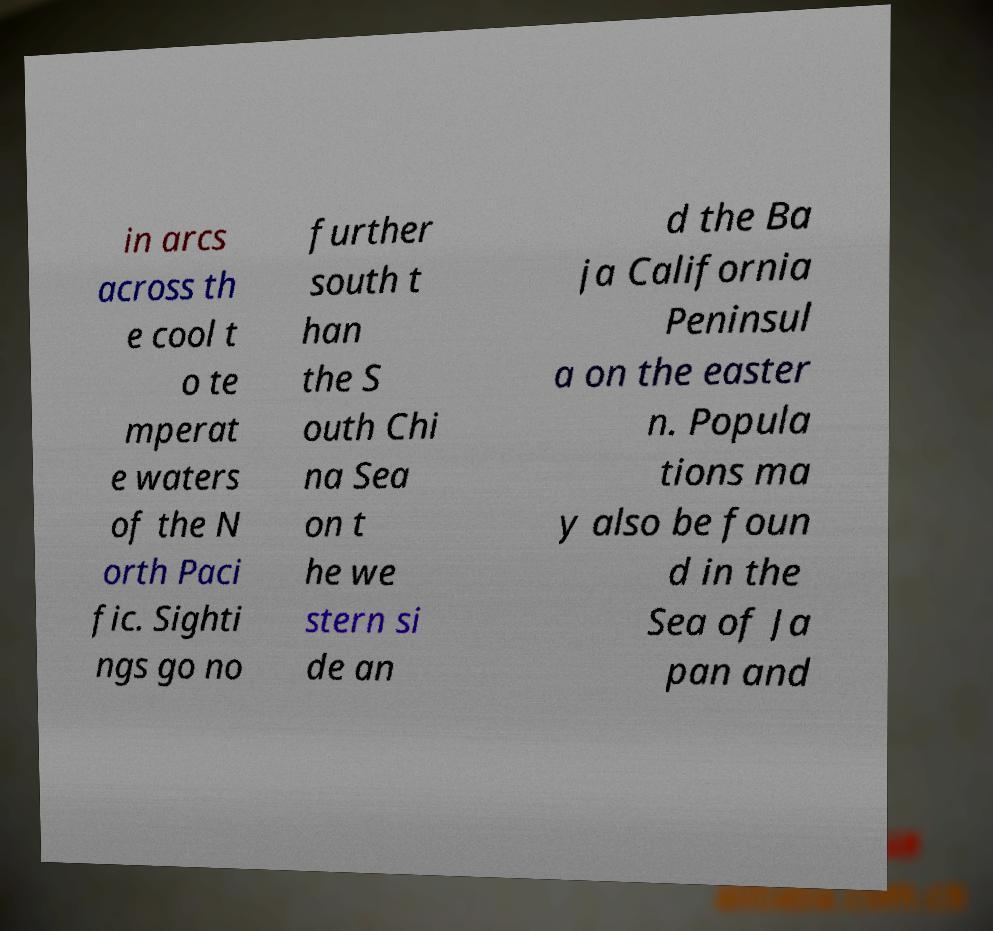Please identify and transcribe the text found in this image. in arcs across th e cool t o te mperat e waters of the N orth Paci fic. Sighti ngs go no further south t han the S outh Chi na Sea on t he we stern si de an d the Ba ja California Peninsul a on the easter n. Popula tions ma y also be foun d in the Sea of Ja pan and 